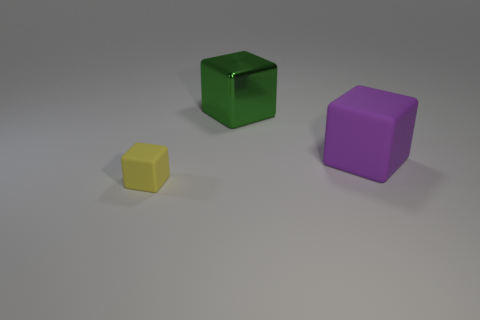Subtract 1 blocks. How many blocks are left? 2 Subtract all yellow blocks. How many blocks are left? 2 Subtract all cyan blocks. Subtract all yellow balls. How many blocks are left? 3 Subtract all brown cylinders. How many red blocks are left? 0 Subtract all large red metal spheres. Subtract all big matte things. How many objects are left? 2 Add 1 big shiny cubes. How many big shiny cubes are left? 2 Add 3 large things. How many large things exist? 5 Add 1 purple matte cylinders. How many objects exist? 4 Subtract all purple cubes. How many cubes are left? 2 Subtract 0 brown blocks. How many objects are left? 3 